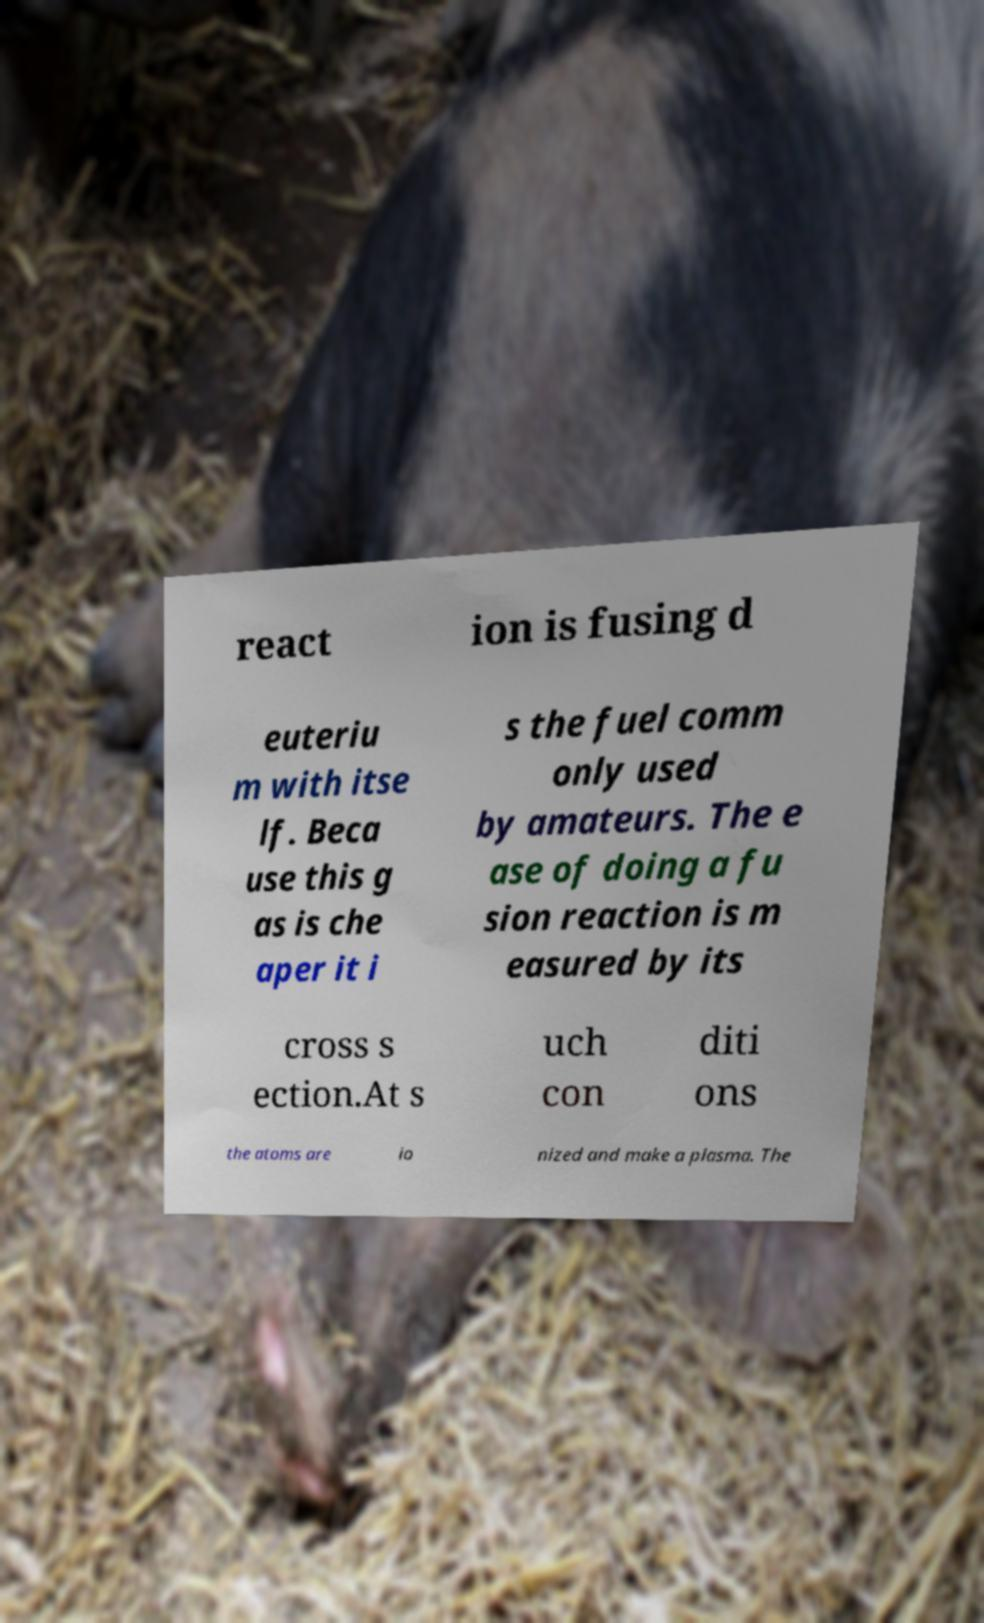For documentation purposes, I need the text within this image transcribed. Could you provide that? react ion is fusing d euteriu m with itse lf. Beca use this g as is che aper it i s the fuel comm only used by amateurs. The e ase of doing a fu sion reaction is m easured by its cross s ection.At s uch con diti ons the atoms are io nized and make a plasma. The 